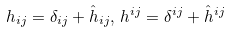Convert formula to latex. <formula><loc_0><loc_0><loc_500><loc_500>h _ { i j } = \delta _ { i j } + \hat { h } _ { i j } , \, h ^ { i j } = \delta ^ { i j } + \hat { h } ^ { i j }</formula> 